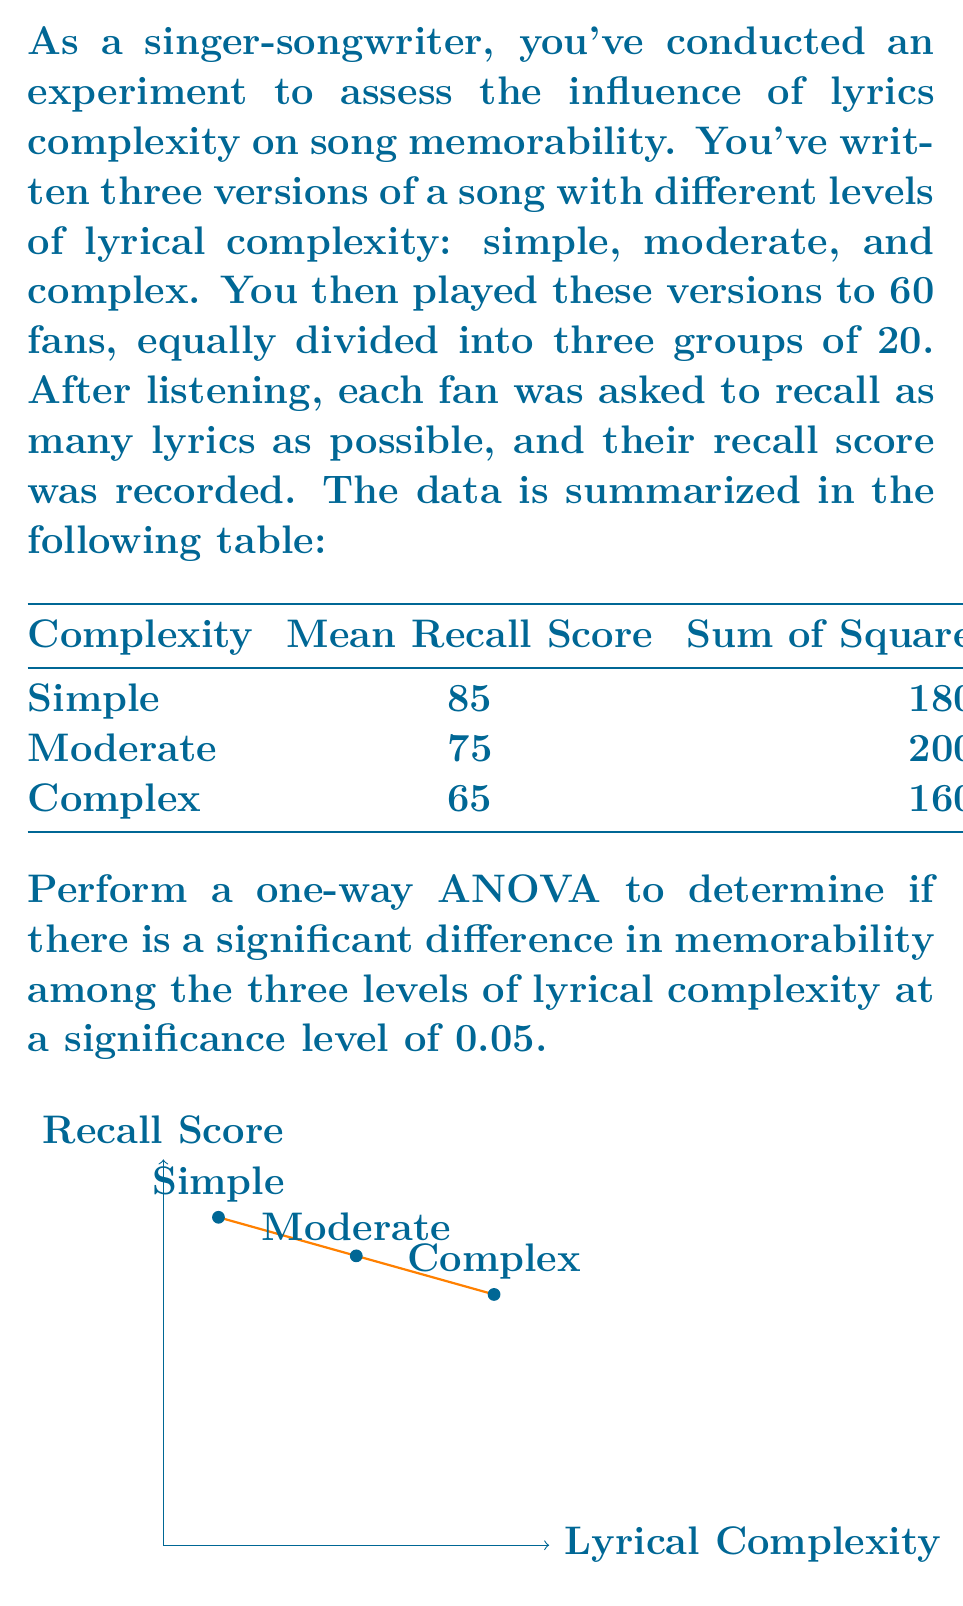Give your solution to this math problem. Let's perform the one-way ANOVA step by step:

1) First, calculate the total sum of squares (SST):
   $$SST = \sum_{i=1}^{3} SS_i = 1800 + 2000 + 1600 = 5400$$

2) Calculate the between-group sum of squares (SSB):
   $$SSB = \sum_{i=1}^{3} n_i(\bar{x}_i - \bar{x})^2$$
   where $n_i = 20$ for each group, $\bar{x}_i$ are the group means, and $\bar{x}$ is the grand mean.
   
   Grand mean: $\bar{x} = \frac{85 + 75 + 65}{3} = 75$
   
   $$SSB = 20[(85-75)^2 + (75-75)^2 + (65-75)^2] = 20(100 + 0 + 100) = 4000$$

3) Calculate the within-group sum of squares (SSW):
   $$SSW = SST - SSB = 5400 - 4000 = 1400$$

4) Calculate degrees of freedom:
   - Between groups: $df_B = k - 1 = 3 - 1 = 2$
   - Within groups: $df_W = N - k = 60 - 3 = 57$
   - Total: $df_T = N - 1 = 60 - 1 = 59$

5) Calculate mean squares:
   $$MSB = \frac{SSB}{df_B} = \frac{4000}{2} = 2000$$
   $$MSW = \frac{SSW}{df_W} = \frac{1400}{57} \approx 24.56$$

6) Calculate the F-statistic:
   $$F = \frac{MSB}{MSW} = \frac{2000}{24.56} \approx 81.43$$

7) Find the critical F-value:
   For $\alpha = 0.05$, $df_B = 2$, and $df_W = 57$, the critical F-value is approximately 3.16.

8) Compare the F-statistic to the critical F-value:
   Since 81.43 > 3.16, we reject the null hypothesis.

Therefore, there is a significant difference in memorability among the three levels of lyrical complexity at the 0.05 significance level.
Answer: $F(2,57) = 81.43, p < 0.05$. Reject null hypothesis. 